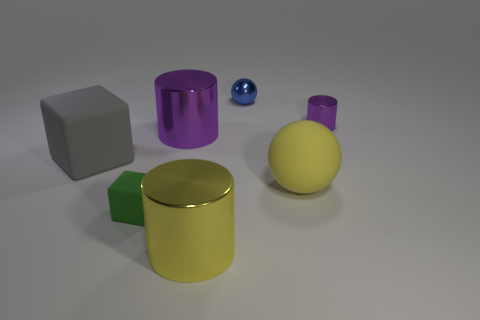What material is the large cylinder that is the same color as the small metallic cylinder?
Make the answer very short. Metal. Are there an equal number of purple metallic cylinders that are to the right of the large sphere and large yellow metallic objects?
Your answer should be compact. Yes. What color is the metal ball that is the same size as the green rubber thing?
Your response must be concise. Blue. Are there any big yellow objects of the same shape as the large gray rubber thing?
Make the answer very short. No. There is a purple cylinder on the left side of the tiny metallic thing behind the tiny metal thing that is in front of the tiny sphere; what is it made of?
Ensure brevity in your answer.  Metal. How many other things are the same size as the green rubber cube?
Ensure brevity in your answer.  2. What is the color of the small shiny sphere?
Your response must be concise. Blue. How many metal things are either yellow things or brown blocks?
Make the answer very short. 1. Is there anything else that has the same material as the small blue object?
Make the answer very short. Yes. What size is the sphere behind the large metal cylinder to the left of the large shiny thing that is in front of the big purple cylinder?
Keep it short and to the point. Small. 